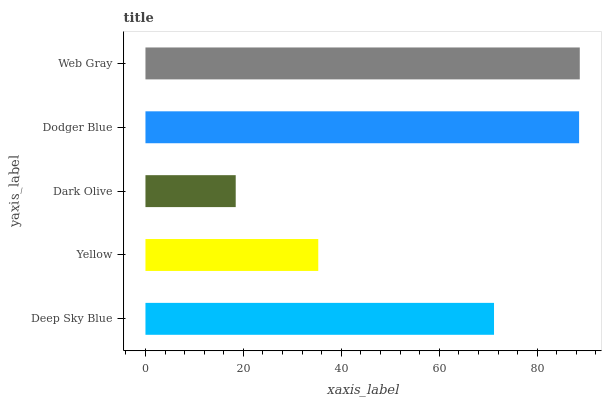Is Dark Olive the minimum?
Answer yes or no. Yes. Is Web Gray the maximum?
Answer yes or no. Yes. Is Yellow the minimum?
Answer yes or no. No. Is Yellow the maximum?
Answer yes or no. No. Is Deep Sky Blue greater than Yellow?
Answer yes or no. Yes. Is Yellow less than Deep Sky Blue?
Answer yes or no. Yes. Is Yellow greater than Deep Sky Blue?
Answer yes or no. No. Is Deep Sky Blue less than Yellow?
Answer yes or no. No. Is Deep Sky Blue the high median?
Answer yes or no. Yes. Is Deep Sky Blue the low median?
Answer yes or no. Yes. Is Web Gray the high median?
Answer yes or no. No. Is Yellow the low median?
Answer yes or no. No. 